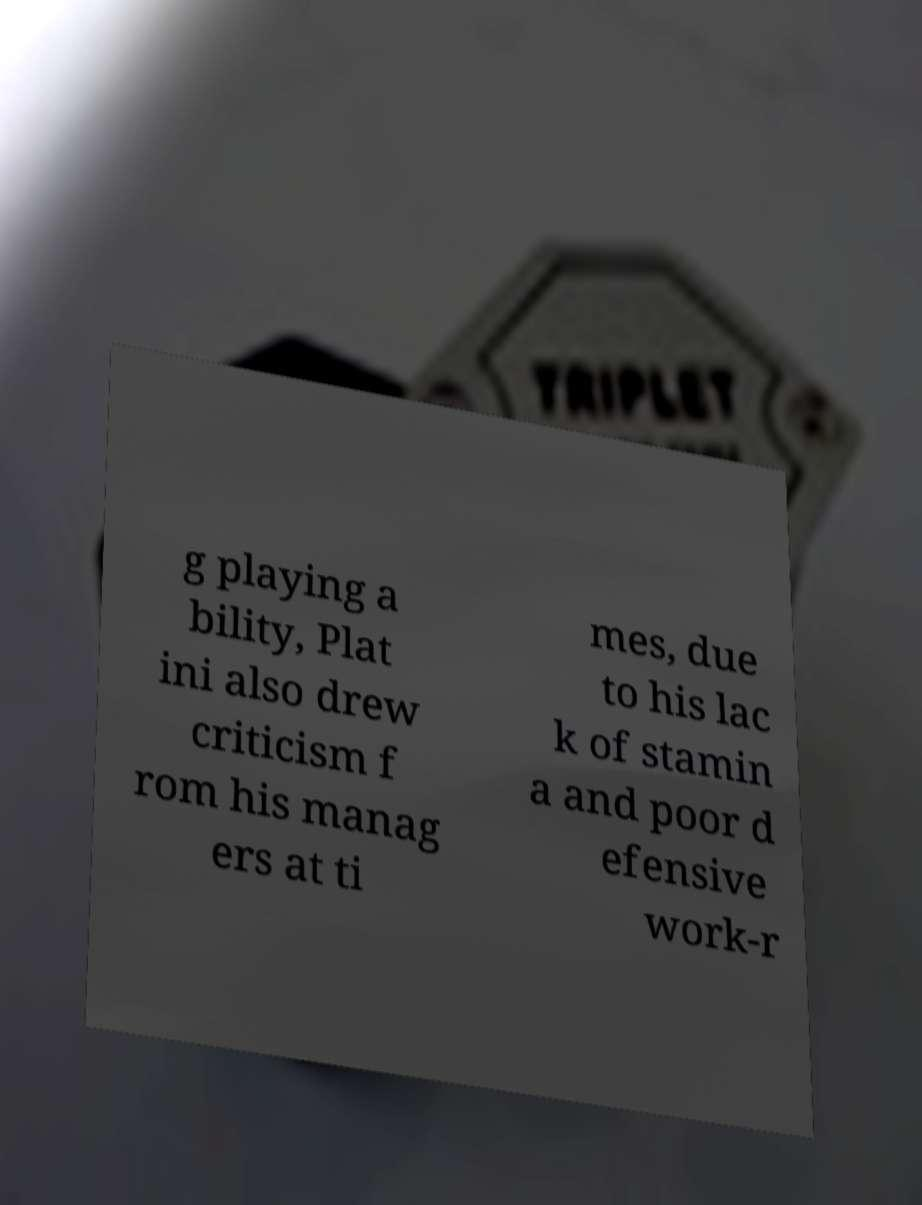There's text embedded in this image that I need extracted. Can you transcribe it verbatim? g playing a bility, Plat ini also drew criticism f rom his manag ers at ti mes, due to his lac k of stamin a and poor d efensive work-r 